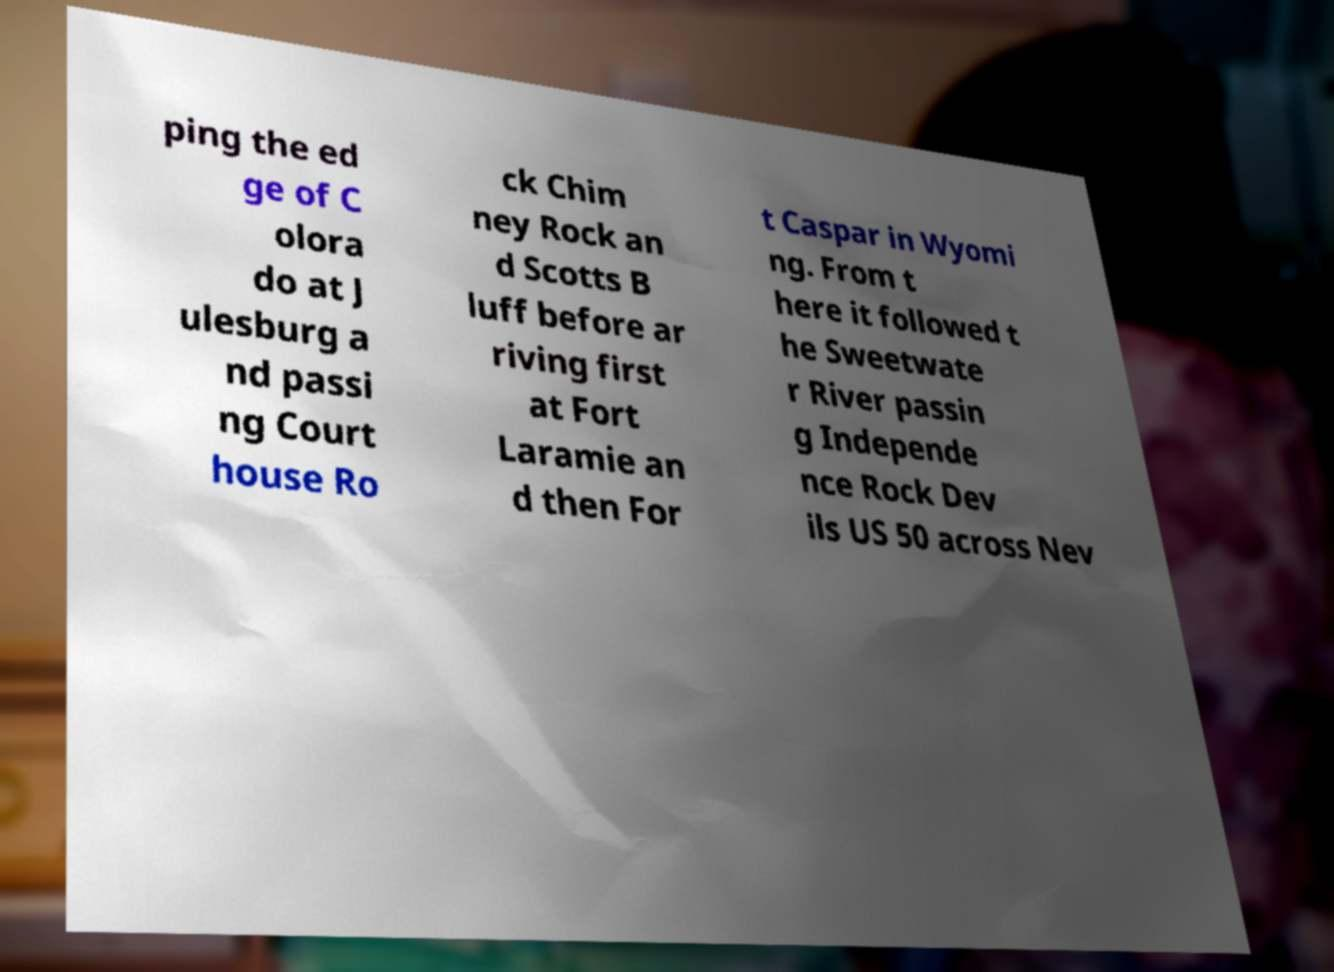There's text embedded in this image that I need extracted. Can you transcribe it verbatim? ping the ed ge of C olora do at J ulesburg a nd passi ng Court house Ro ck Chim ney Rock an d Scotts B luff before ar riving first at Fort Laramie an d then For t Caspar in Wyomi ng. From t here it followed t he Sweetwate r River passin g Independe nce Rock Dev ils US 50 across Nev 